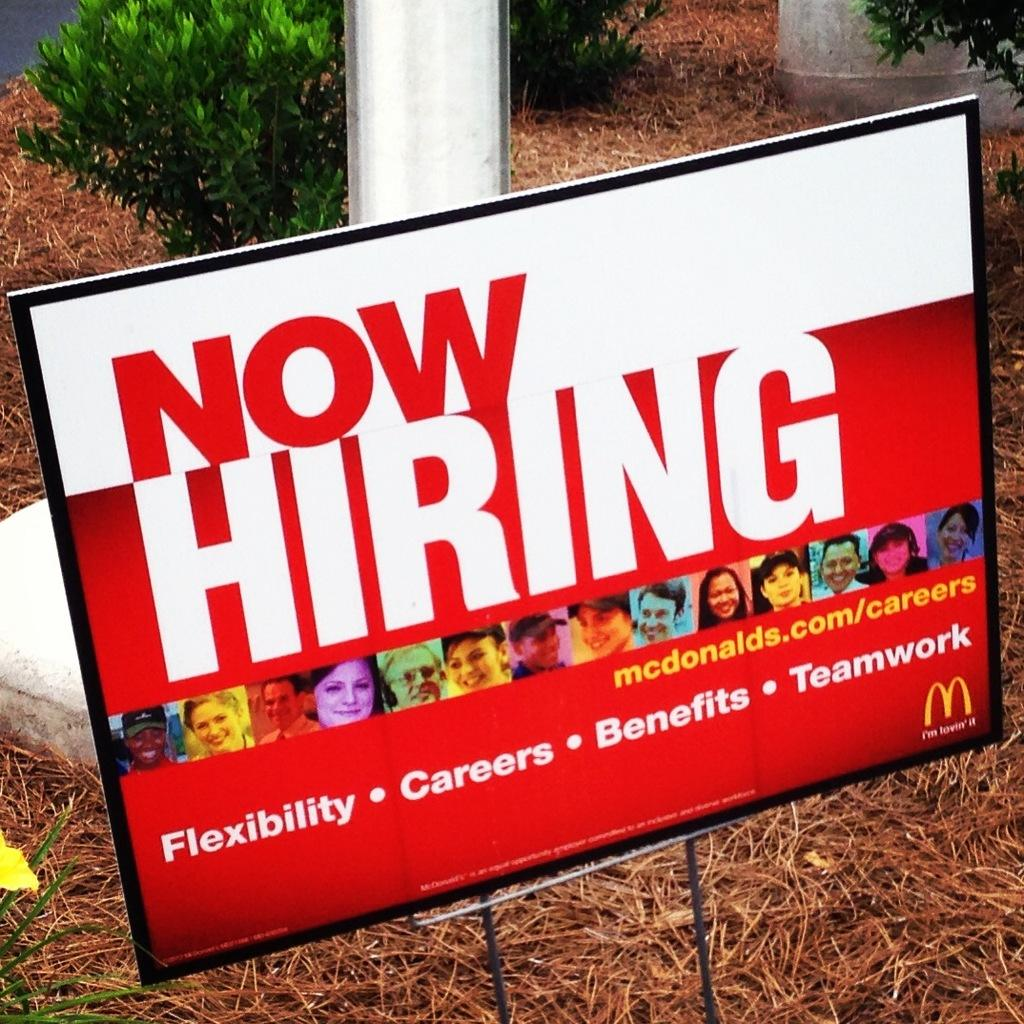What is the main object in the image? There is a board in the image. What type of vegetation is at the bottom of the image? Dry grass is present at the bottom of the image. What can be seen in the background of the image? There is a pole and green plants visible in the background of the image. What is the price of the minister in the image? There is no minister or price mentioned in the image; it only features a board, dry grass, a pole, and green plants. 